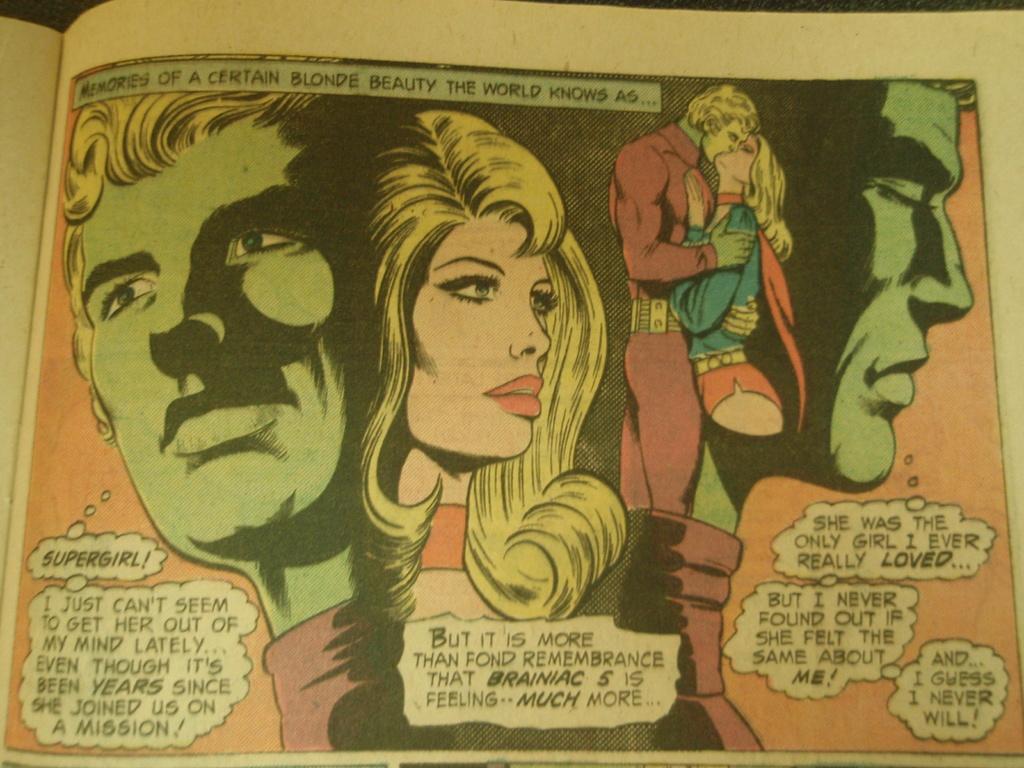Who is the woman in the center of the image?
Offer a terse response. Supergirl. What is in the last bubble on the right?
Give a very brief answer. And i guess i never will. 